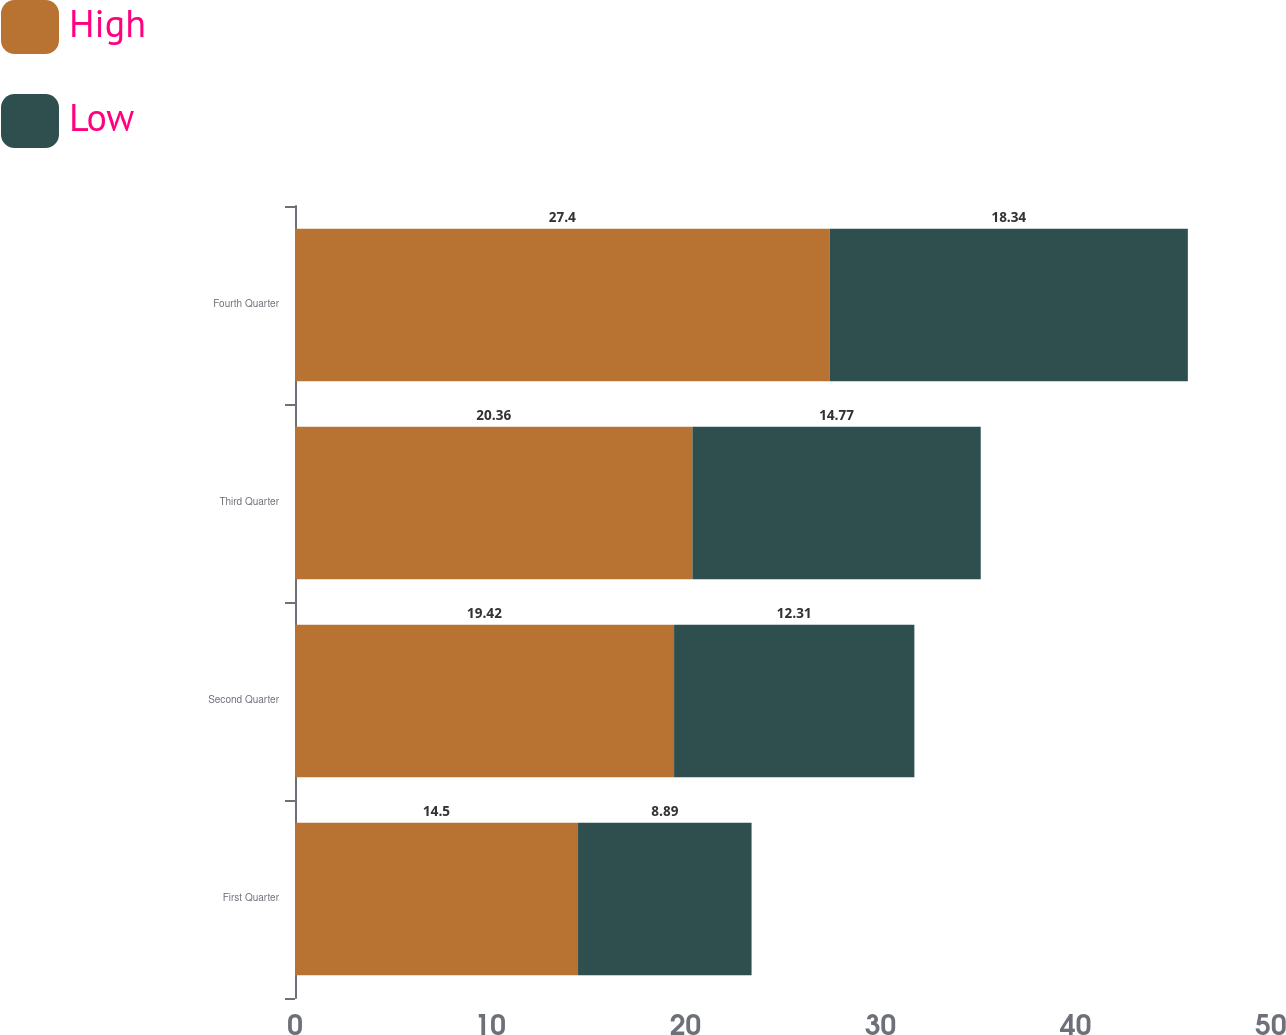Convert chart. <chart><loc_0><loc_0><loc_500><loc_500><stacked_bar_chart><ecel><fcel>First Quarter<fcel>Second Quarter<fcel>Third Quarter<fcel>Fourth Quarter<nl><fcel>High<fcel>14.5<fcel>19.42<fcel>20.36<fcel>27.4<nl><fcel>Low<fcel>8.89<fcel>12.31<fcel>14.77<fcel>18.34<nl></chart> 